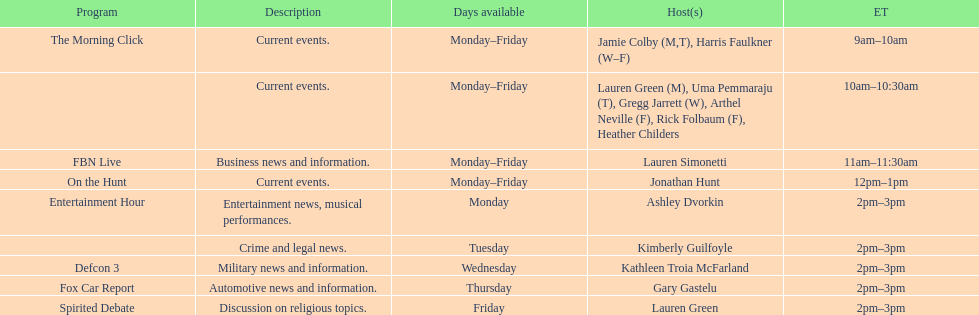How long does on the hunt run? 1 hour. 